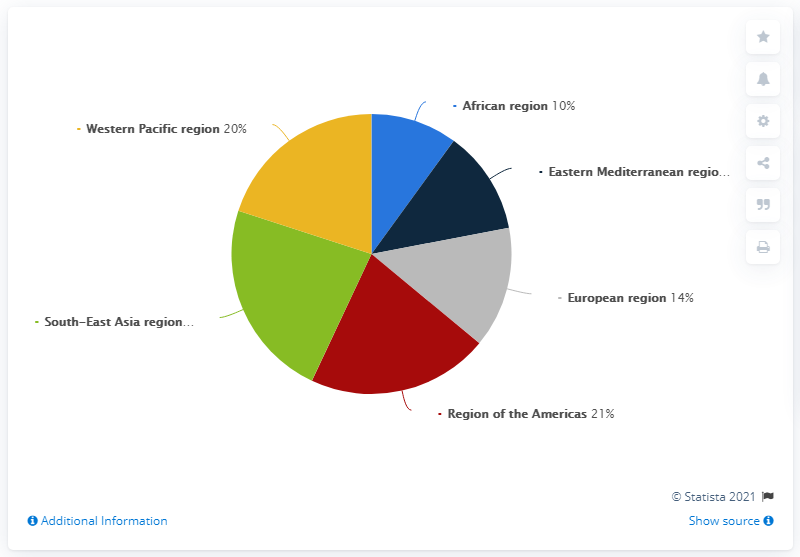Draw attention to some important aspects in this diagram. The ratio of the Western Pacific region to the African region is 2:1. The graph represents 6 countries. According to a study conducted in 2015, in South-East Asia, approximately 23% of cases of anxiety disorders were reported. 